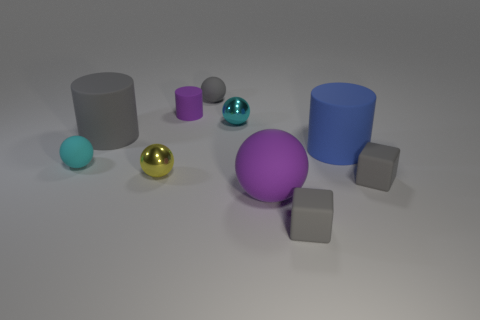Are there the same number of large rubber objects to the right of the tiny purple object and tiny gray matte things on the left side of the blue matte cylinder?
Provide a short and direct response. Yes. There is a cyan ball that is made of the same material as the big blue cylinder; what size is it?
Offer a terse response. Small. The small matte cylinder is what color?
Provide a succinct answer. Purple. What number of small matte objects are the same color as the tiny cylinder?
Your answer should be very brief. 0. There is a gray ball that is the same size as the purple matte cylinder; what is its material?
Your response must be concise. Rubber. Is there a sphere in front of the small rubber thing on the left side of the tiny purple cylinder?
Provide a succinct answer. Yes. What size is the gray rubber cylinder?
Offer a terse response. Large. Are there any large green cubes?
Ensure brevity in your answer.  No. Are there more big things on the left side of the small gray matte ball than small cyan metal things that are on the left side of the tiny yellow object?
Provide a succinct answer. Yes. What is the ball that is to the right of the small cyan rubber thing and on the left side of the tiny purple cylinder made of?
Your response must be concise. Metal. 